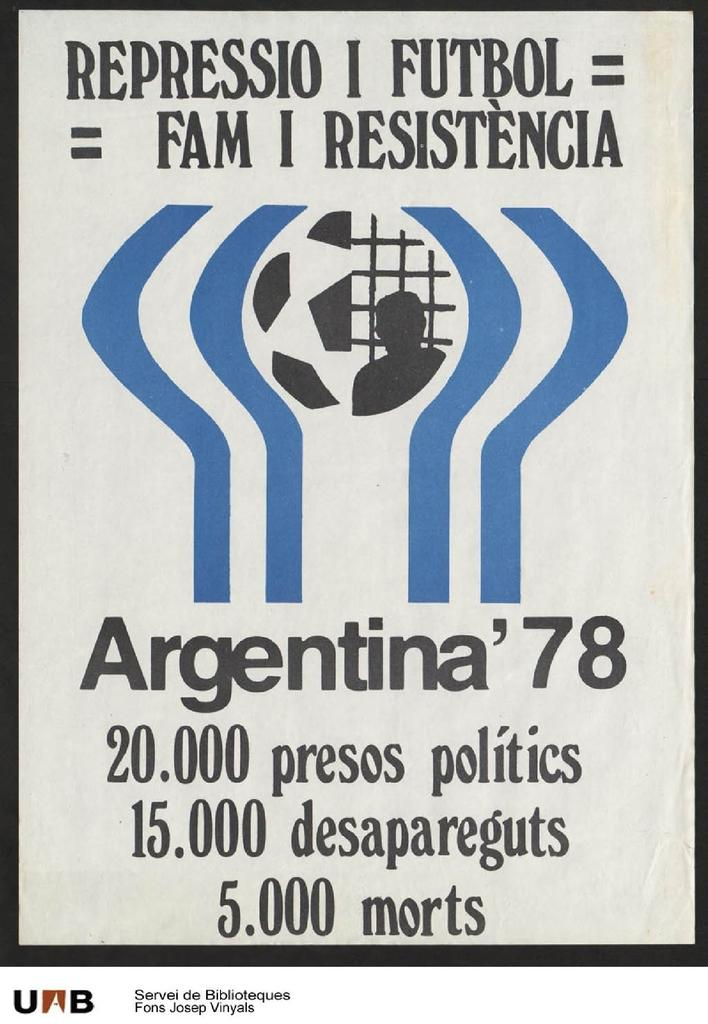<image>
Share a concise interpretation of the image provided. poster for repressio i futbol with a admission price of 20 presos 